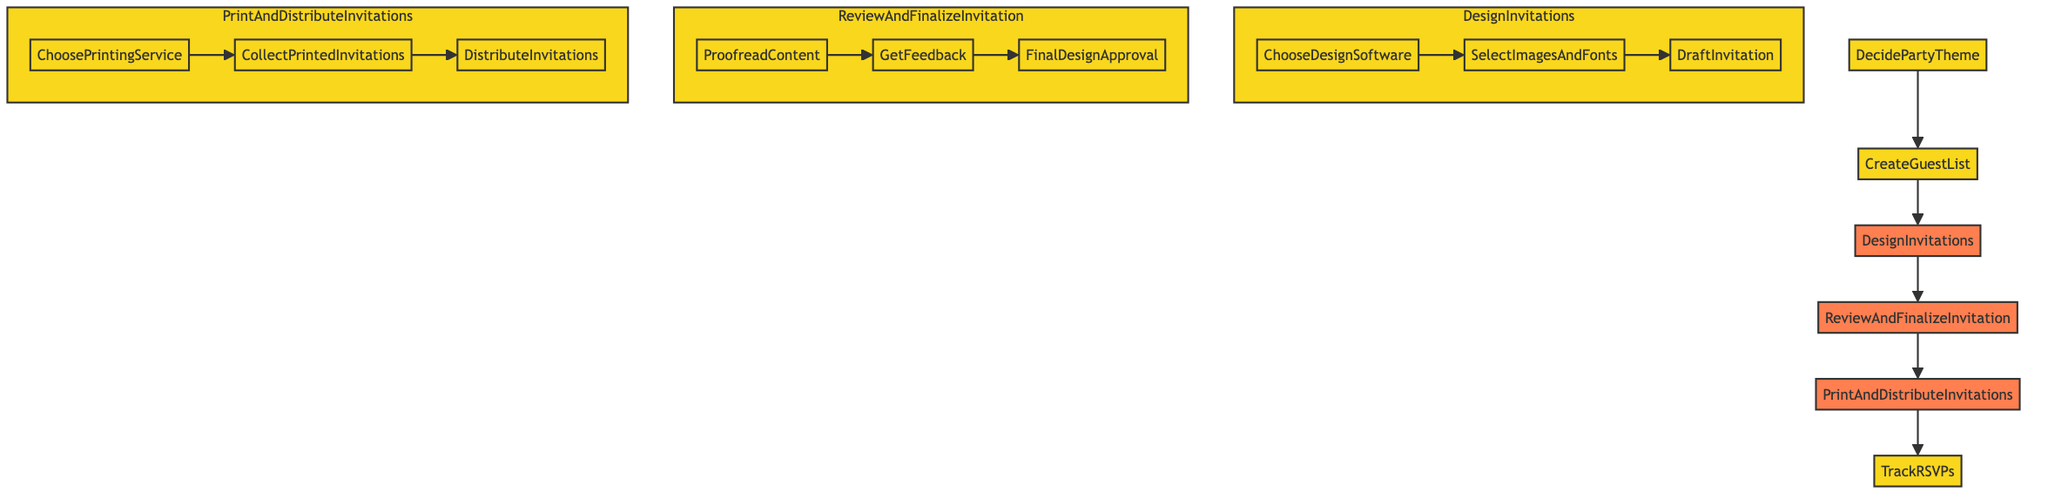What is the first step in the process? The first step is clearly indicated in the diagram as "DecidePartyTheme". It is the starting point of the flowchart, leading to the next step.
Answer: DecidePartyTheme How many main steps are in the process? By counting the main steps outlined in the diagram, we see there are five key steps before tracking RSVPs. These are sequentially arranged from deciding the theme to tracking responses.
Answer: Five What is needed to create invitations? The diagram specifies "DesignInvitations" as the process that needs to be carried out to prepare invitations. This is further broken down into substeps that detail the requirements for invitation creation.
Answer: DesignInvitations Which substep comes after "ProofreadContent"? According to the flowchart, "ProofreadContent" is followed directly by "GetFeedback". These two substeps are part of the overall step "ReviewAndFinalizeInvitation".
Answer: GetFeedback What is the last main step in the process? The final main step, as indicated at the end of the flowchart, is "TrackRSVPs". This step monitors the responses from the invitation distribution phase.
Answer: TrackRSVPs What comes before "CollectPrintedInvitations"? The flowchart shows "ChoosePrintingService" leading directly into "CollectPrintedInvitations". Thus, the step prior to collecting printed invitations is choosing a printing service.
Answer: ChoosePrintingService How are invitations distributed? The diagram explains that "DistributeInvitations" is the final substep in the "PrintAndDistributeInvitations" process, indicating the methods for sending out invitations after printing.
Answer: DistributeInvitations What are the three substeps in "DesignInvitations"? The flowchart outlines three specific substeps under "DesignInvitations": "ChooseDesignSoftware", "SelectImagesAndFonts", and "DraftInvitation". These steps are crucial for creating the invitations.
Answer: ChooseDesignSoftware, SelectImagesAndFonts, DraftInvitation What is the relationship between "CreateGuestList" and "DesignInvitations"? The flowchart illustrates a sequential relationship where "CreateGuestList" directly leads to "DesignInvitations", indicating that guest list creation must precede the design of invitations.
Answer: Sequential relationship 